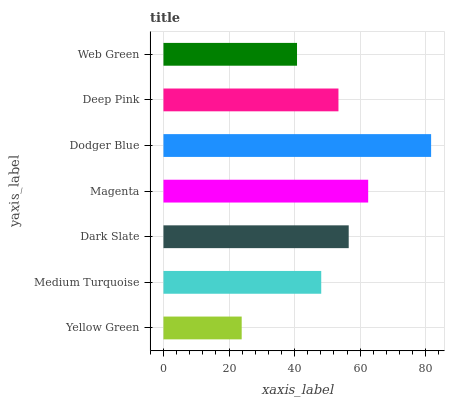Is Yellow Green the minimum?
Answer yes or no. Yes. Is Dodger Blue the maximum?
Answer yes or no. Yes. Is Medium Turquoise the minimum?
Answer yes or no. No. Is Medium Turquoise the maximum?
Answer yes or no. No. Is Medium Turquoise greater than Yellow Green?
Answer yes or no. Yes. Is Yellow Green less than Medium Turquoise?
Answer yes or no. Yes. Is Yellow Green greater than Medium Turquoise?
Answer yes or no. No. Is Medium Turquoise less than Yellow Green?
Answer yes or no. No. Is Deep Pink the high median?
Answer yes or no. Yes. Is Deep Pink the low median?
Answer yes or no. Yes. Is Dodger Blue the high median?
Answer yes or no. No. Is Web Green the low median?
Answer yes or no. No. 